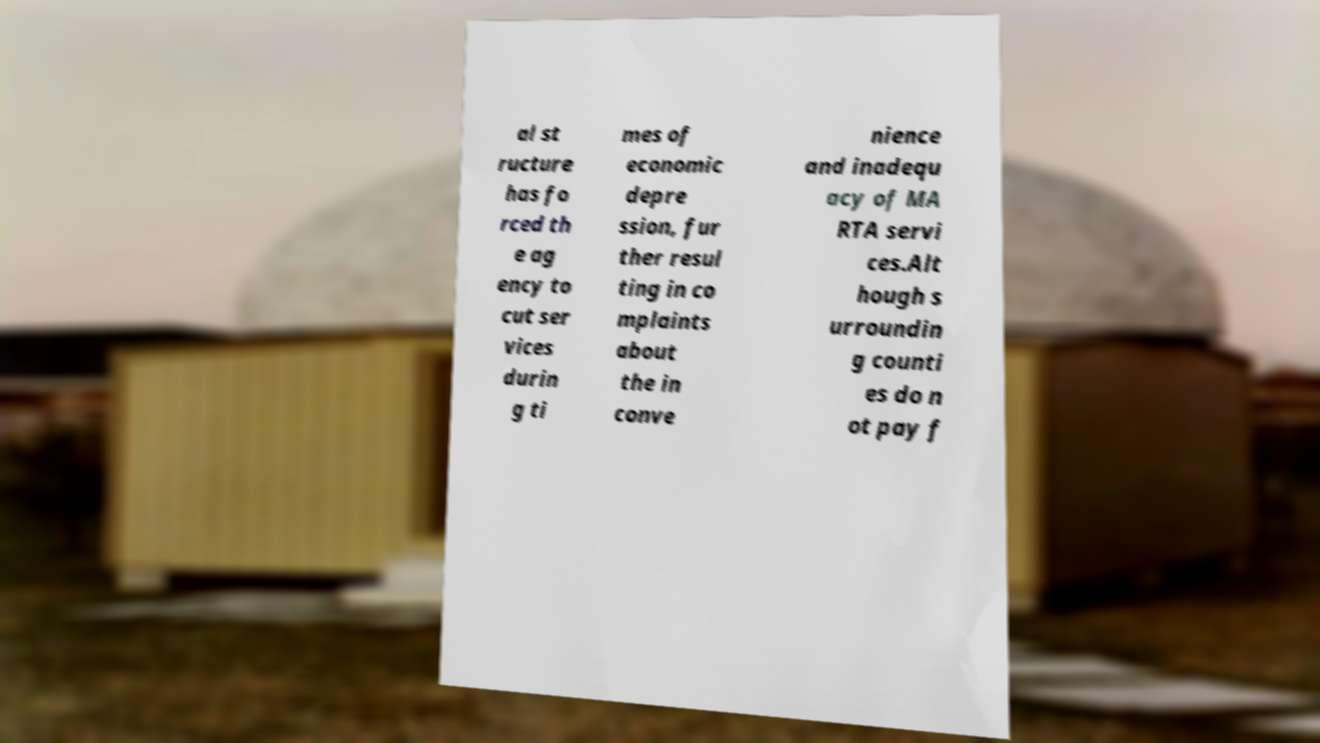Can you accurately transcribe the text from the provided image for me? al st ructure has fo rced th e ag ency to cut ser vices durin g ti mes of economic depre ssion, fur ther resul ting in co mplaints about the in conve nience and inadequ acy of MA RTA servi ces.Alt hough s urroundin g counti es do n ot pay f 